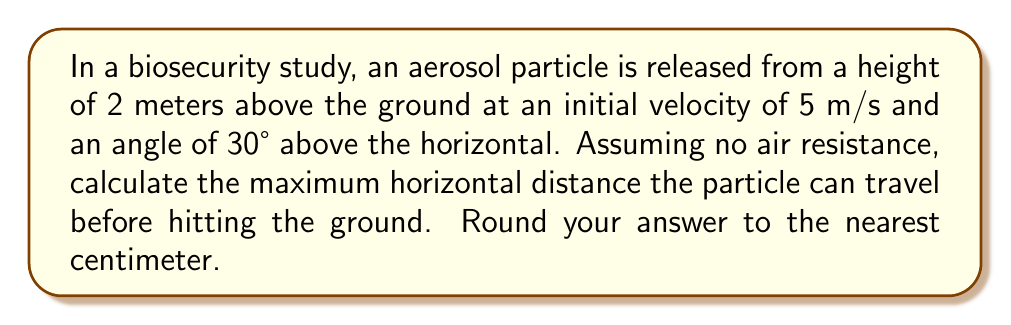Can you answer this question? To solve this problem, we'll use the equations of projectile motion and trigonometry. Let's break it down step-by-step:

1) First, we need to determine the initial velocity components:
   $v_{0x} = v_0 \cos \theta = 5 \cos 30° = 5 \cdot \frac{\sqrt{3}}{2} = 2.5\sqrt{3}$ m/s
   $v_{0y} = v_0 \sin \theta = 5 \sin 30° = 5 \cdot \frac{1}{2} = 2.5$ m/s

2) The time of flight can be calculated using the vertical motion equation:
   $y = y_0 + v_{0y}t - \frac{1}{2}gt^2$
   
   At the point of impact, $y = 0$ and $y_0 = 2$ m. Substituting:
   $0 = 2 + 2.5t - 4.9t^2$

3) Solving this quadratic equation:
   $4.9t^2 - 2.5t - 2 = 0$
   $t = \frac{2.5 \pm \sqrt{6.25 + 39.2}}{9.8} = \frac{2.5 \pm \sqrt{45.45}}{9.8}$

   Taking the positive root (as time can't be negative):
   $t = \frac{2.5 + 6.74}{9.8} = 0.94$ seconds

4) Now that we have the time of flight, we can calculate the horizontal distance:
   $x = v_{0x}t = 2.5\sqrt{3} \cdot 0.94 = 4.07$ m

5) Rounding to the nearest centimeter:
   4.07 m = 407 cm
Answer: 407 cm 